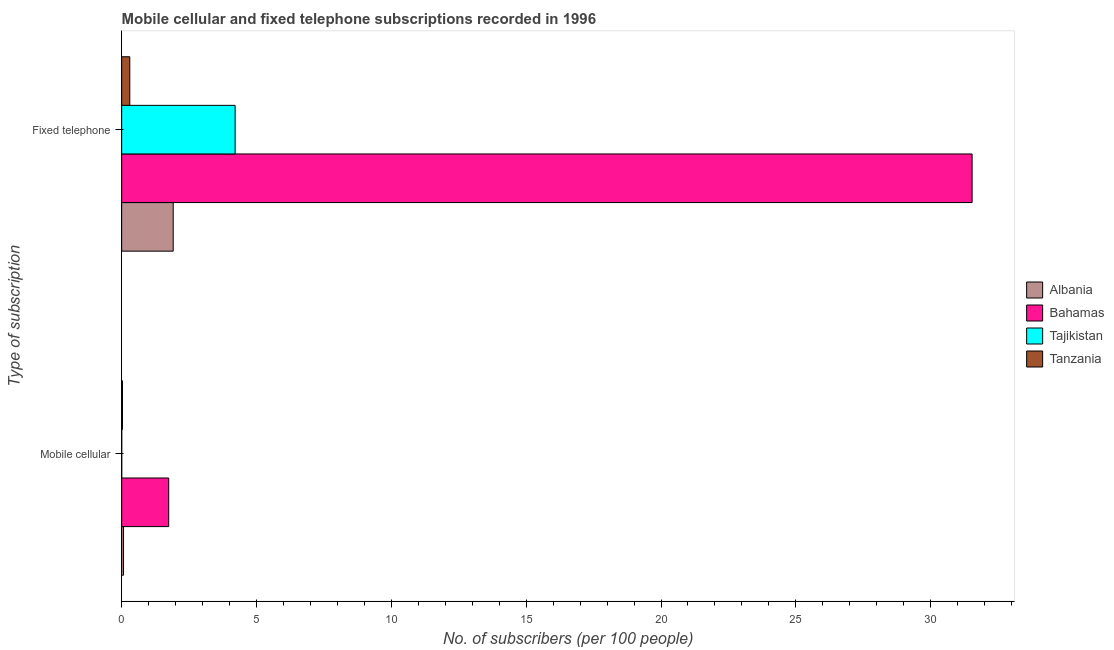How many different coloured bars are there?
Offer a terse response. 4. Are the number of bars on each tick of the Y-axis equal?
Your response must be concise. Yes. How many bars are there on the 2nd tick from the bottom?
Offer a very short reply. 4. What is the label of the 2nd group of bars from the top?
Keep it short and to the point. Mobile cellular. What is the number of mobile cellular subscribers in Tanzania?
Provide a short and direct response. 0.03. Across all countries, what is the maximum number of fixed telephone subscribers?
Your answer should be very brief. 31.54. Across all countries, what is the minimum number of mobile cellular subscribers?
Give a very brief answer. 0. In which country was the number of fixed telephone subscribers maximum?
Offer a very short reply. Bahamas. In which country was the number of fixed telephone subscribers minimum?
Provide a short and direct response. Tanzania. What is the total number of fixed telephone subscribers in the graph?
Provide a short and direct response. 37.96. What is the difference between the number of mobile cellular subscribers in Bahamas and that in Albania?
Provide a succinct answer. 1.68. What is the difference between the number of fixed telephone subscribers in Albania and the number of mobile cellular subscribers in Tanzania?
Offer a terse response. 1.88. What is the average number of fixed telephone subscribers per country?
Your answer should be very brief. 9.49. What is the difference between the number of fixed telephone subscribers and number of mobile cellular subscribers in Albania?
Provide a succinct answer. 1.84. In how many countries, is the number of fixed telephone subscribers greater than 24 ?
Your response must be concise. 1. What is the ratio of the number of mobile cellular subscribers in Tanzania to that in Albania?
Ensure brevity in your answer.  0.43. In how many countries, is the number of mobile cellular subscribers greater than the average number of mobile cellular subscribers taken over all countries?
Offer a very short reply. 1. What does the 2nd bar from the top in Mobile cellular represents?
Keep it short and to the point. Tajikistan. What does the 4th bar from the bottom in Mobile cellular represents?
Ensure brevity in your answer.  Tanzania. How many countries are there in the graph?
Keep it short and to the point. 4. Does the graph contain grids?
Your answer should be very brief. No. Where does the legend appear in the graph?
Ensure brevity in your answer.  Center right. How are the legend labels stacked?
Offer a very short reply. Vertical. What is the title of the graph?
Give a very brief answer. Mobile cellular and fixed telephone subscriptions recorded in 1996. Does "Ireland" appear as one of the legend labels in the graph?
Give a very brief answer. No. What is the label or title of the X-axis?
Offer a very short reply. No. of subscribers (per 100 people). What is the label or title of the Y-axis?
Provide a short and direct response. Type of subscription. What is the No. of subscribers (per 100 people) of Albania in Mobile cellular?
Ensure brevity in your answer.  0.07. What is the No. of subscribers (per 100 people) in Bahamas in Mobile cellular?
Your answer should be compact. 1.74. What is the No. of subscribers (per 100 people) in Tajikistan in Mobile cellular?
Offer a terse response. 0. What is the No. of subscribers (per 100 people) of Tanzania in Mobile cellular?
Your answer should be compact. 0.03. What is the No. of subscribers (per 100 people) in Albania in Fixed telephone?
Offer a terse response. 1.91. What is the No. of subscribers (per 100 people) of Bahamas in Fixed telephone?
Make the answer very short. 31.54. What is the No. of subscribers (per 100 people) of Tajikistan in Fixed telephone?
Offer a terse response. 4.21. What is the No. of subscribers (per 100 people) of Tanzania in Fixed telephone?
Ensure brevity in your answer.  0.3. Across all Type of subscription, what is the maximum No. of subscribers (per 100 people) in Albania?
Keep it short and to the point. 1.91. Across all Type of subscription, what is the maximum No. of subscribers (per 100 people) of Bahamas?
Provide a succinct answer. 31.54. Across all Type of subscription, what is the maximum No. of subscribers (per 100 people) in Tajikistan?
Make the answer very short. 4.21. Across all Type of subscription, what is the maximum No. of subscribers (per 100 people) in Tanzania?
Offer a terse response. 0.3. Across all Type of subscription, what is the minimum No. of subscribers (per 100 people) of Albania?
Keep it short and to the point. 0.07. Across all Type of subscription, what is the minimum No. of subscribers (per 100 people) in Bahamas?
Give a very brief answer. 1.74. Across all Type of subscription, what is the minimum No. of subscribers (per 100 people) of Tajikistan?
Give a very brief answer. 0. Across all Type of subscription, what is the minimum No. of subscribers (per 100 people) of Tanzania?
Keep it short and to the point. 0.03. What is the total No. of subscribers (per 100 people) in Albania in the graph?
Your answer should be very brief. 1.98. What is the total No. of subscribers (per 100 people) of Bahamas in the graph?
Ensure brevity in your answer.  33.28. What is the total No. of subscribers (per 100 people) in Tajikistan in the graph?
Keep it short and to the point. 4.21. What is the total No. of subscribers (per 100 people) of Tanzania in the graph?
Offer a very short reply. 0.33. What is the difference between the No. of subscribers (per 100 people) in Albania in Mobile cellular and that in Fixed telephone?
Offer a very short reply. -1.84. What is the difference between the No. of subscribers (per 100 people) of Bahamas in Mobile cellular and that in Fixed telephone?
Offer a very short reply. -29.79. What is the difference between the No. of subscribers (per 100 people) in Tajikistan in Mobile cellular and that in Fixed telephone?
Your answer should be compact. -4.21. What is the difference between the No. of subscribers (per 100 people) in Tanzania in Mobile cellular and that in Fixed telephone?
Your response must be concise. -0.27. What is the difference between the No. of subscribers (per 100 people) in Albania in Mobile cellular and the No. of subscribers (per 100 people) in Bahamas in Fixed telephone?
Ensure brevity in your answer.  -31.47. What is the difference between the No. of subscribers (per 100 people) of Albania in Mobile cellular and the No. of subscribers (per 100 people) of Tajikistan in Fixed telephone?
Keep it short and to the point. -4.14. What is the difference between the No. of subscribers (per 100 people) in Albania in Mobile cellular and the No. of subscribers (per 100 people) in Tanzania in Fixed telephone?
Provide a succinct answer. -0.23. What is the difference between the No. of subscribers (per 100 people) in Bahamas in Mobile cellular and the No. of subscribers (per 100 people) in Tajikistan in Fixed telephone?
Your answer should be compact. -2.46. What is the difference between the No. of subscribers (per 100 people) of Bahamas in Mobile cellular and the No. of subscribers (per 100 people) of Tanzania in Fixed telephone?
Your answer should be very brief. 1.44. What is the difference between the No. of subscribers (per 100 people) of Tajikistan in Mobile cellular and the No. of subscribers (per 100 people) of Tanzania in Fixed telephone?
Keep it short and to the point. -0.3. What is the average No. of subscribers (per 100 people) in Albania per Type of subscription?
Offer a terse response. 0.99. What is the average No. of subscribers (per 100 people) in Bahamas per Type of subscription?
Provide a short and direct response. 16.64. What is the average No. of subscribers (per 100 people) of Tajikistan per Type of subscription?
Your answer should be compact. 2.1. What is the average No. of subscribers (per 100 people) in Tanzania per Type of subscription?
Ensure brevity in your answer.  0.17. What is the difference between the No. of subscribers (per 100 people) in Albania and No. of subscribers (per 100 people) in Bahamas in Mobile cellular?
Provide a succinct answer. -1.68. What is the difference between the No. of subscribers (per 100 people) in Albania and No. of subscribers (per 100 people) in Tajikistan in Mobile cellular?
Ensure brevity in your answer.  0.07. What is the difference between the No. of subscribers (per 100 people) of Albania and No. of subscribers (per 100 people) of Tanzania in Mobile cellular?
Make the answer very short. 0.04. What is the difference between the No. of subscribers (per 100 people) in Bahamas and No. of subscribers (per 100 people) in Tajikistan in Mobile cellular?
Ensure brevity in your answer.  1.74. What is the difference between the No. of subscribers (per 100 people) of Bahamas and No. of subscribers (per 100 people) of Tanzania in Mobile cellular?
Offer a terse response. 1.71. What is the difference between the No. of subscribers (per 100 people) of Tajikistan and No. of subscribers (per 100 people) of Tanzania in Mobile cellular?
Offer a very short reply. -0.03. What is the difference between the No. of subscribers (per 100 people) in Albania and No. of subscribers (per 100 people) in Bahamas in Fixed telephone?
Offer a terse response. -29.63. What is the difference between the No. of subscribers (per 100 people) of Albania and No. of subscribers (per 100 people) of Tajikistan in Fixed telephone?
Keep it short and to the point. -2.3. What is the difference between the No. of subscribers (per 100 people) in Albania and No. of subscribers (per 100 people) in Tanzania in Fixed telephone?
Keep it short and to the point. 1.61. What is the difference between the No. of subscribers (per 100 people) in Bahamas and No. of subscribers (per 100 people) in Tajikistan in Fixed telephone?
Your answer should be very brief. 27.33. What is the difference between the No. of subscribers (per 100 people) of Bahamas and No. of subscribers (per 100 people) of Tanzania in Fixed telephone?
Keep it short and to the point. 31.24. What is the difference between the No. of subscribers (per 100 people) of Tajikistan and No. of subscribers (per 100 people) of Tanzania in Fixed telephone?
Offer a very short reply. 3.91. What is the ratio of the No. of subscribers (per 100 people) in Albania in Mobile cellular to that in Fixed telephone?
Your answer should be compact. 0.04. What is the ratio of the No. of subscribers (per 100 people) of Bahamas in Mobile cellular to that in Fixed telephone?
Give a very brief answer. 0.06. What is the ratio of the No. of subscribers (per 100 people) of Tajikistan in Mobile cellular to that in Fixed telephone?
Offer a very short reply. 0. What is the ratio of the No. of subscribers (per 100 people) of Tanzania in Mobile cellular to that in Fixed telephone?
Ensure brevity in your answer.  0.1. What is the difference between the highest and the second highest No. of subscribers (per 100 people) in Albania?
Keep it short and to the point. 1.84. What is the difference between the highest and the second highest No. of subscribers (per 100 people) in Bahamas?
Your answer should be compact. 29.79. What is the difference between the highest and the second highest No. of subscribers (per 100 people) in Tajikistan?
Your response must be concise. 4.21. What is the difference between the highest and the second highest No. of subscribers (per 100 people) in Tanzania?
Ensure brevity in your answer.  0.27. What is the difference between the highest and the lowest No. of subscribers (per 100 people) in Albania?
Ensure brevity in your answer.  1.84. What is the difference between the highest and the lowest No. of subscribers (per 100 people) in Bahamas?
Your answer should be very brief. 29.79. What is the difference between the highest and the lowest No. of subscribers (per 100 people) in Tajikistan?
Provide a succinct answer. 4.21. What is the difference between the highest and the lowest No. of subscribers (per 100 people) in Tanzania?
Your answer should be compact. 0.27. 